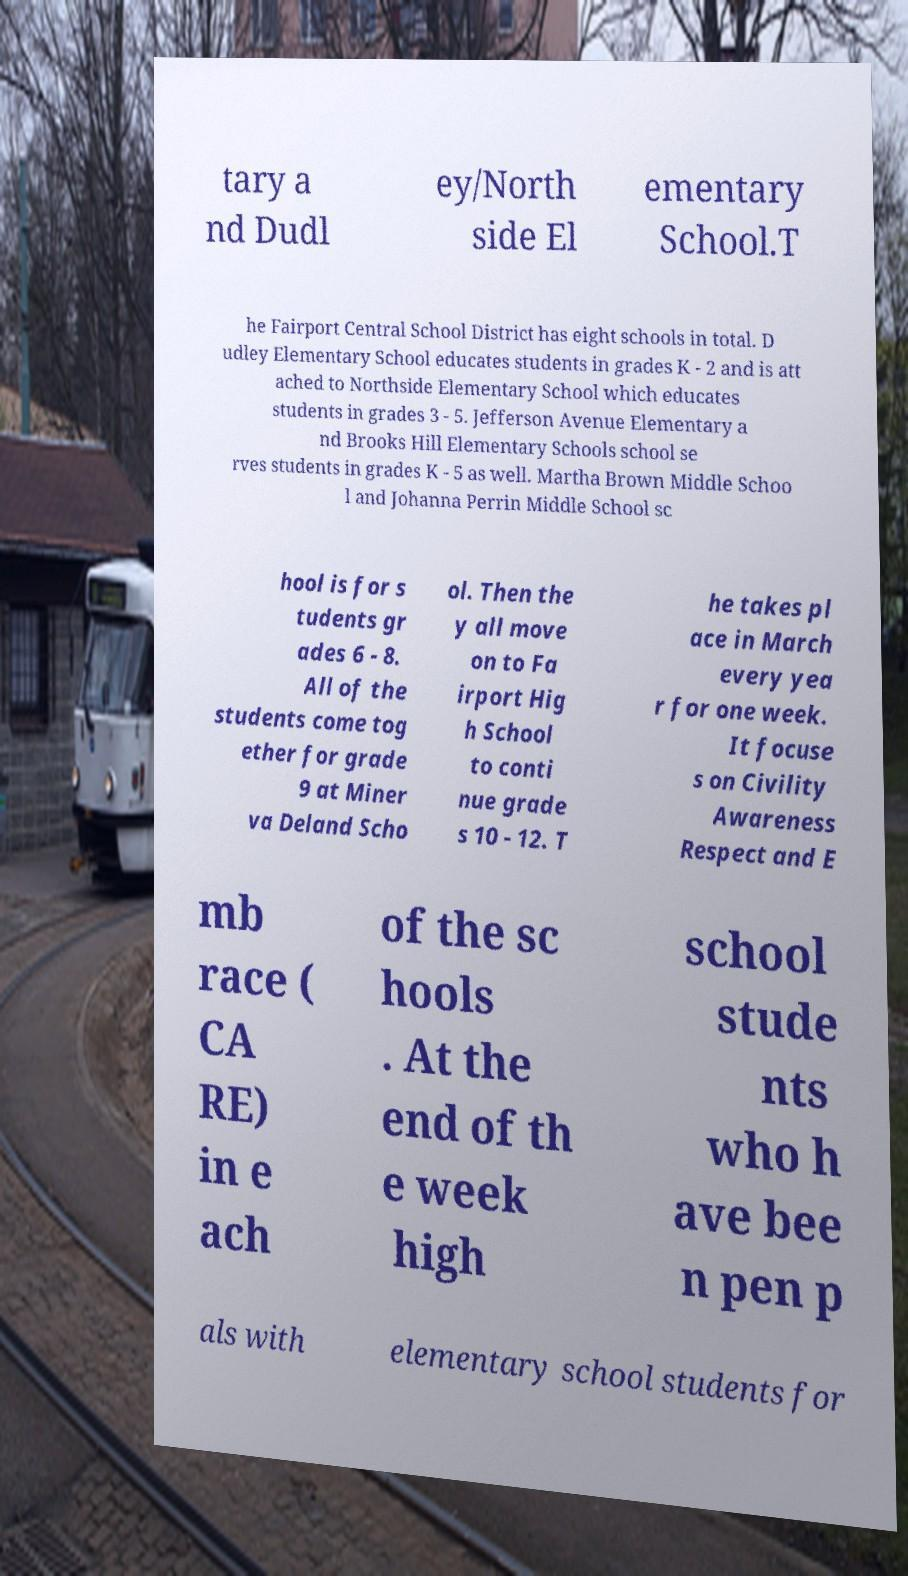Please read and relay the text visible in this image. What does it say? tary a nd Dudl ey/North side El ementary School.T he Fairport Central School District has eight schools in total. D udley Elementary School educates students in grades K - 2 and is att ached to Northside Elementary School which educates students in grades 3 - 5. Jefferson Avenue Elementary a nd Brooks Hill Elementary Schools school se rves students in grades K - 5 as well. Martha Brown Middle Schoo l and Johanna Perrin Middle School sc hool is for s tudents gr ades 6 - 8. All of the students come tog ether for grade 9 at Miner va Deland Scho ol. Then the y all move on to Fa irport Hig h School to conti nue grade s 10 - 12. T he takes pl ace in March every yea r for one week. It focuse s on Civility Awareness Respect and E mb race ( CA RE) in e ach of the sc hools . At the end of th e week high school stude nts who h ave bee n pen p als with elementary school students for 